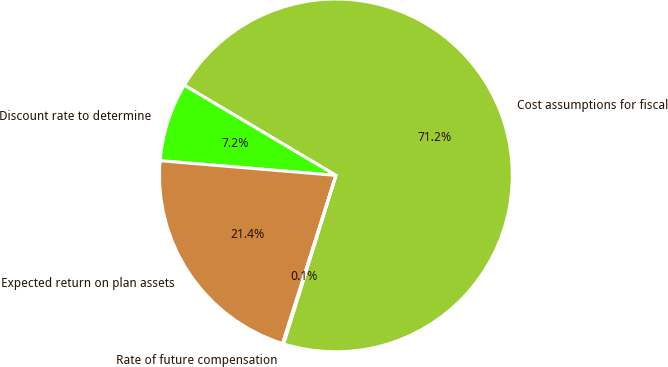Convert chart to OTSL. <chart><loc_0><loc_0><loc_500><loc_500><pie_chart><fcel>Cost assumptions for fiscal<fcel>Discount rate to determine<fcel>Expected return on plan assets<fcel>Rate of future compensation<nl><fcel>71.25%<fcel>7.21%<fcel>21.44%<fcel>0.1%<nl></chart> 